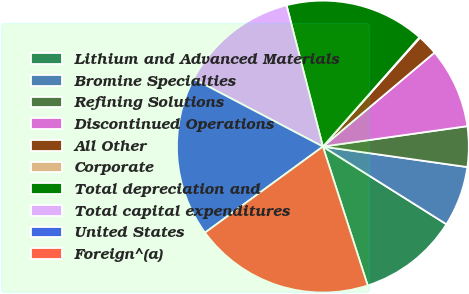Convert chart to OTSL. <chart><loc_0><loc_0><loc_500><loc_500><pie_chart><fcel>Lithium and Advanced Materials<fcel>Bromine Specialties<fcel>Refining Solutions<fcel>Discontinued Operations<fcel>All Other<fcel>Corporate<fcel>Total depreciation and<fcel>Total capital expenditures<fcel>United States<fcel>Foreign^(a)<nl><fcel>11.1%<fcel>6.69%<fcel>4.48%<fcel>8.9%<fcel>2.28%<fcel>0.07%<fcel>15.52%<fcel>13.31%<fcel>17.72%<fcel>19.93%<nl></chart> 